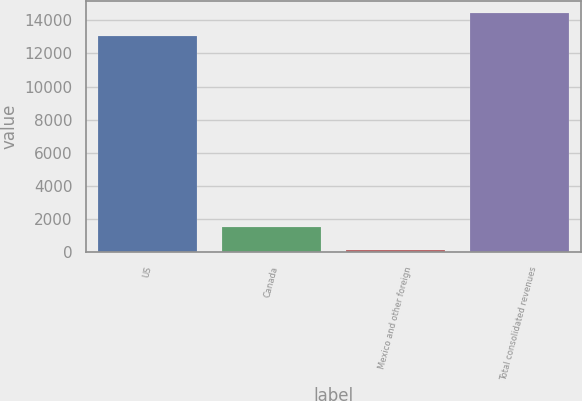Convert chart. <chart><loc_0><loc_0><loc_500><loc_500><bar_chart><fcel>US<fcel>Canada<fcel>Mexico and other foreign<fcel>Total consolidated revenues<nl><fcel>13073<fcel>1486.6<fcel>129<fcel>14430.6<nl></chart> 